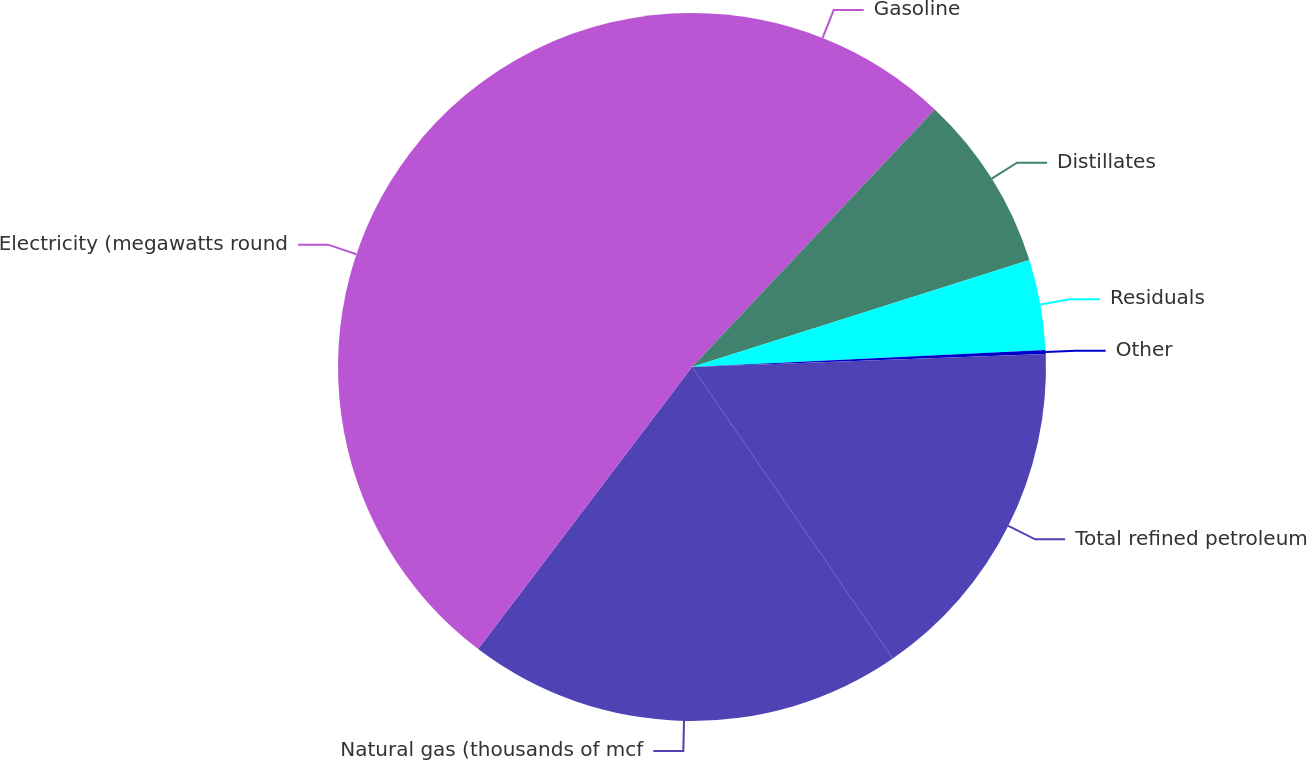Convert chart to OTSL. <chart><loc_0><loc_0><loc_500><loc_500><pie_chart><fcel>Gasoline<fcel>Distillates<fcel>Residuals<fcel>Other<fcel>Total refined petroleum<fcel>Natural gas (thousands of mcf<fcel>Electricity (megawatts round<nl><fcel>12.03%<fcel>8.08%<fcel>4.13%<fcel>0.18%<fcel>15.98%<fcel>19.93%<fcel>39.68%<nl></chart> 